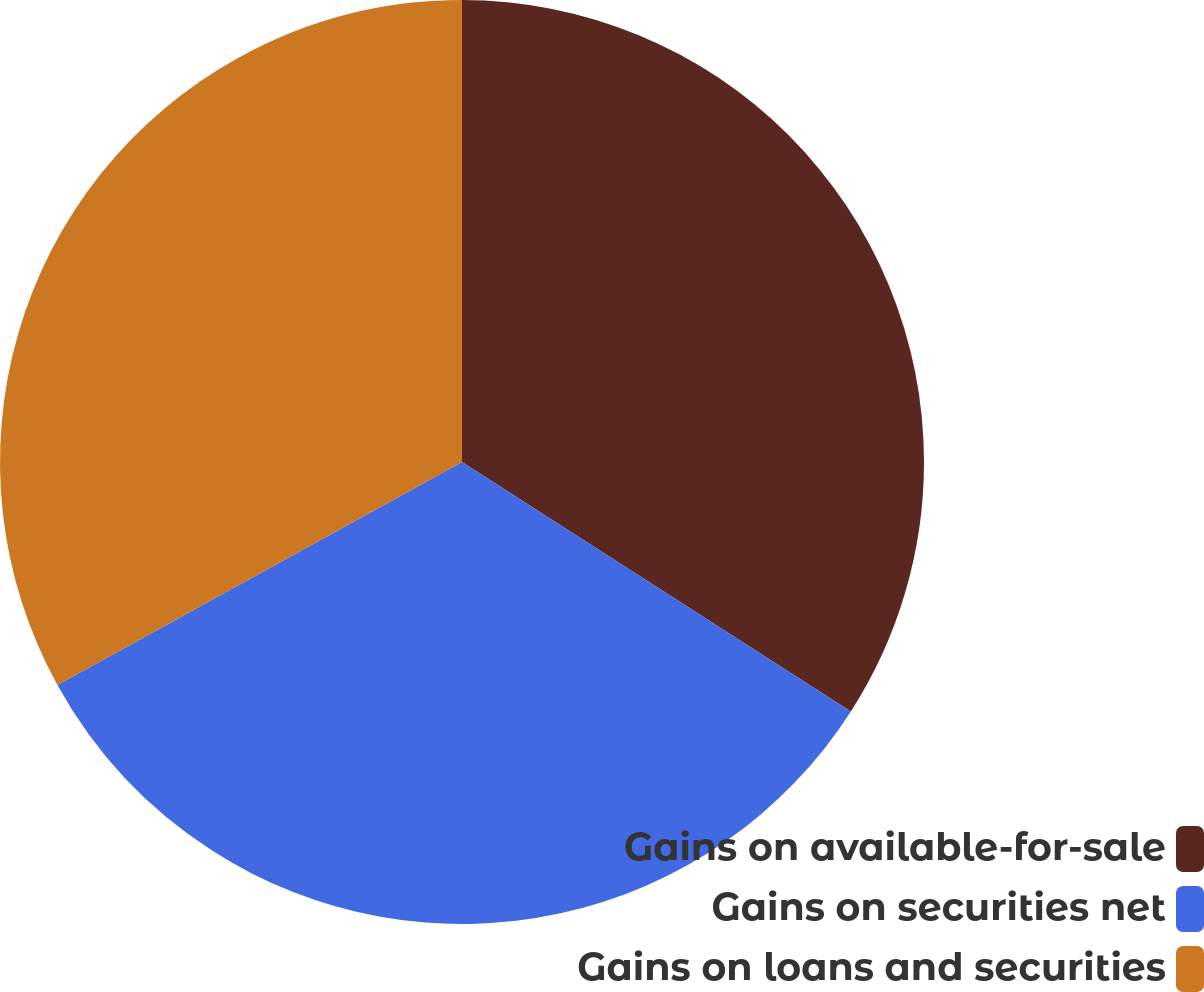Convert chart. <chart><loc_0><loc_0><loc_500><loc_500><pie_chart><fcel>Gains on available-for-sale<fcel>Gains on securities net<fcel>Gains on loans and securities<nl><fcel>34.08%<fcel>32.9%<fcel>33.02%<nl></chart> 